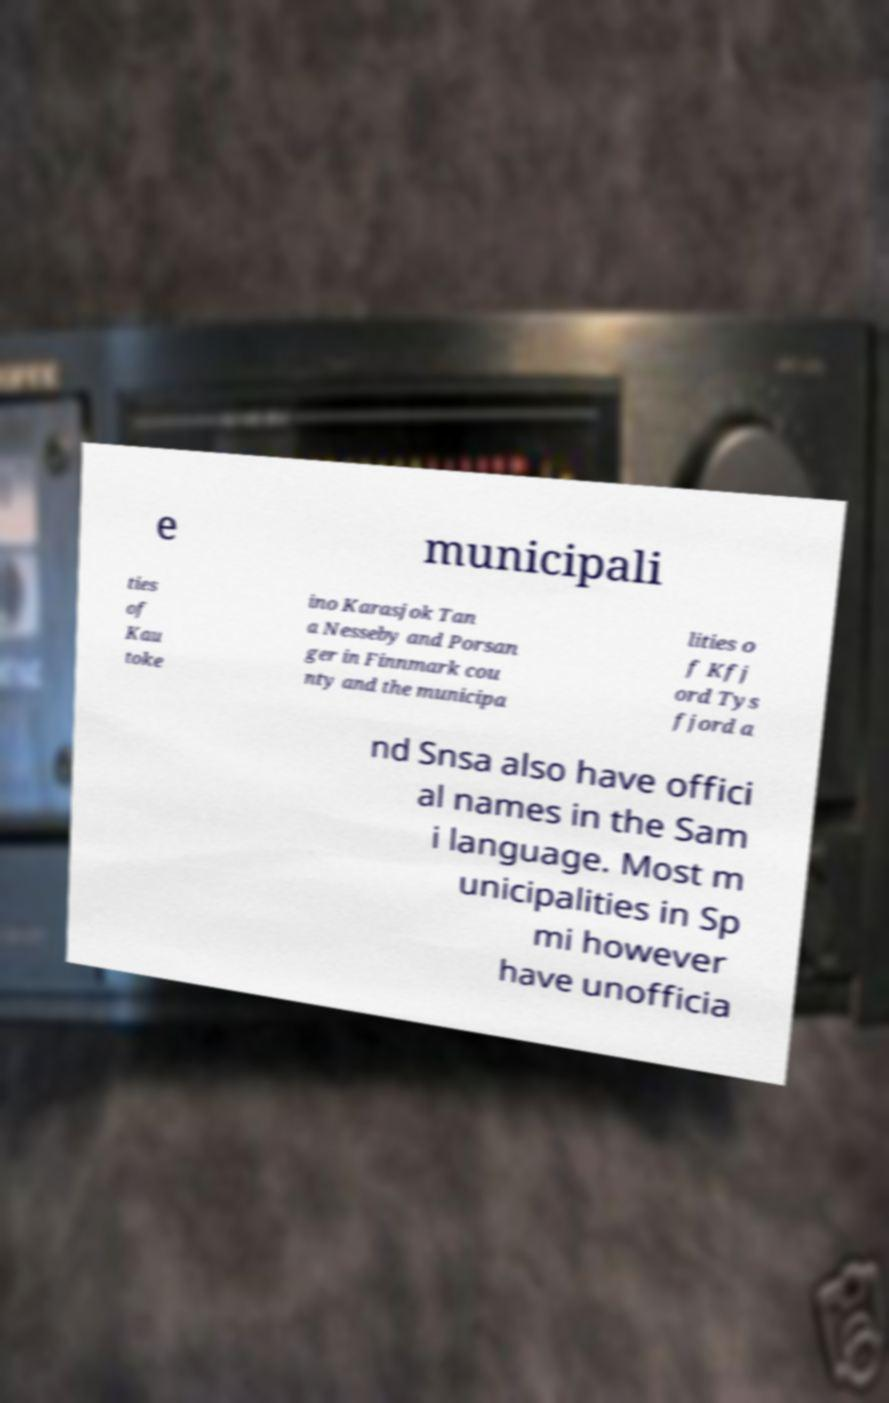There's text embedded in this image that I need extracted. Can you transcribe it verbatim? e municipali ties of Kau toke ino Karasjok Tan a Nesseby and Porsan ger in Finnmark cou nty and the municipa lities o f Kfj ord Tys fjord a nd Snsa also have offici al names in the Sam i language. Most m unicipalities in Sp mi however have unofficia 